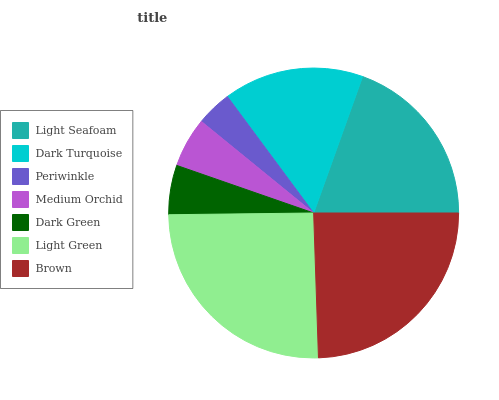Is Periwinkle the minimum?
Answer yes or no. Yes. Is Light Green the maximum?
Answer yes or no. Yes. Is Dark Turquoise the minimum?
Answer yes or no. No. Is Dark Turquoise the maximum?
Answer yes or no. No. Is Light Seafoam greater than Dark Turquoise?
Answer yes or no. Yes. Is Dark Turquoise less than Light Seafoam?
Answer yes or no. Yes. Is Dark Turquoise greater than Light Seafoam?
Answer yes or no. No. Is Light Seafoam less than Dark Turquoise?
Answer yes or no. No. Is Dark Turquoise the high median?
Answer yes or no. Yes. Is Dark Turquoise the low median?
Answer yes or no. Yes. Is Light Green the high median?
Answer yes or no. No. Is Medium Orchid the low median?
Answer yes or no. No. 